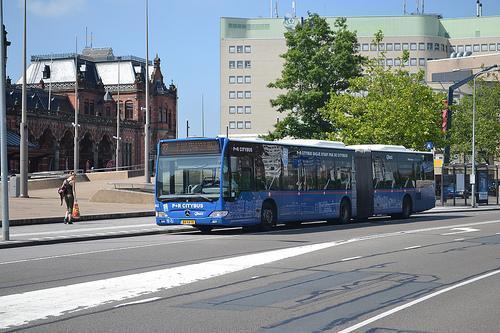How many buildings are there?
Give a very brief answer. 2. 